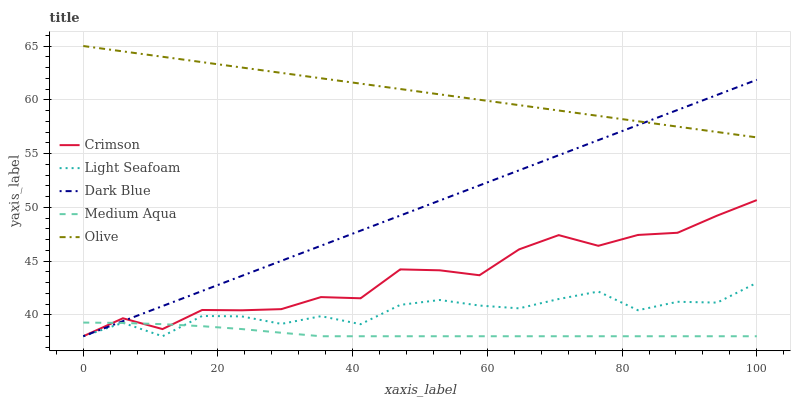Does Medium Aqua have the minimum area under the curve?
Answer yes or no. Yes. Does Olive have the maximum area under the curve?
Answer yes or no. Yes. Does Dark Blue have the minimum area under the curve?
Answer yes or no. No. Does Dark Blue have the maximum area under the curve?
Answer yes or no. No. Is Olive the smoothest?
Answer yes or no. Yes. Is Crimson the roughest?
Answer yes or no. Yes. Is Dark Blue the smoothest?
Answer yes or no. No. Is Dark Blue the roughest?
Answer yes or no. No. Does Crimson have the lowest value?
Answer yes or no. Yes. Does Olive have the lowest value?
Answer yes or no. No. Does Olive have the highest value?
Answer yes or no. Yes. Does Dark Blue have the highest value?
Answer yes or no. No. Is Light Seafoam less than Olive?
Answer yes or no. Yes. Is Olive greater than Medium Aqua?
Answer yes or no. Yes. Does Dark Blue intersect Medium Aqua?
Answer yes or no. Yes. Is Dark Blue less than Medium Aqua?
Answer yes or no. No. Is Dark Blue greater than Medium Aqua?
Answer yes or no. No. Does Light Seafoam intersect Olive?
Answer yes or no. No. 